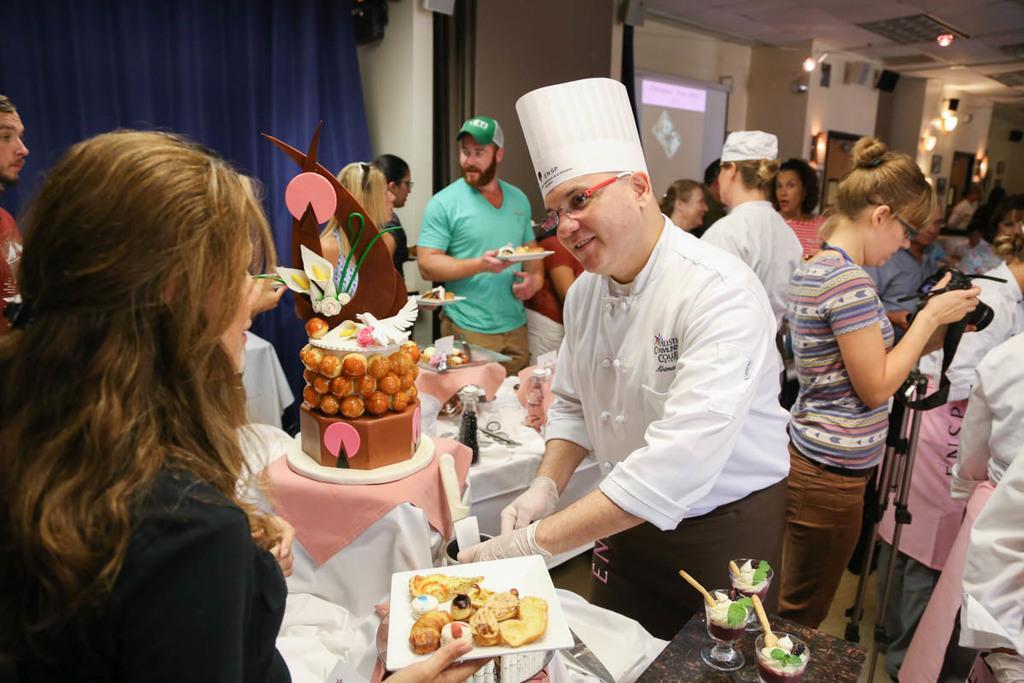How would you summarize this image in a sentence or two? In this image, we can see a few people. We can see some tables covered with a cloth and some food items are placed. We can see the curtain. We can see some doors. We can see the wall with some objects. We can see some lights. We can see the roof. We can see a projector screen. 